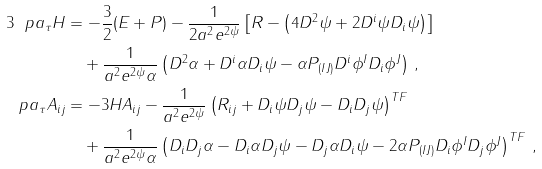<formula> <loc_0><loc_0><loc_500><loc_500>3 \ p a _ { \tau } H & = - \frac { 3 } { 2 } ( E + P ) - \frac { 1 } { 2 a ^ { 2 } e ^ { 2 \psi } } \left [ R - \left ( 4 D ^ { 2 } \psi + 2 D ^ { i } \psi D _ { i } \psi \right ) \right ] \\ & \quad + \frac { 1 } { a ^ { 2 } e ^ { 2 \psi } \alpha } \left ( D ^ { 2 } \alpha + D ^ { i } \alpha D _ { i } \psi - \alpha P _ { ( I J ) } D ^ { i } \phi ^ { I } D _ { i } \phi ^ { J } \right ) \, , \\ \ p a _ { \tau } A _ { i j } & = - 3 H A _ { i j } - \frac { 1 } { a ^ { 2 } e ^ { 2 \psi } } \left ( R _ { i j } + D _ { i } \psi D _ { j } \psi - D _ { i } D _ { j } \psi \right ) ^ { T F } \\ & \quad + \frac { 1 } { a ^ { 2 } e ^ { 2 \psi } \alpha } \left ( D _ { i } D _ { j } \alpha - D _ { i } \alpha D _ { j } \psi - D _ { j } \alpha D _ { i } \psi - 2 \alpha P _ { ( I J ) } D _ { i } \phi ^ { I } D _ { j } \phi ^ { J } \right ) ^ { T F } \, ,</formula> 